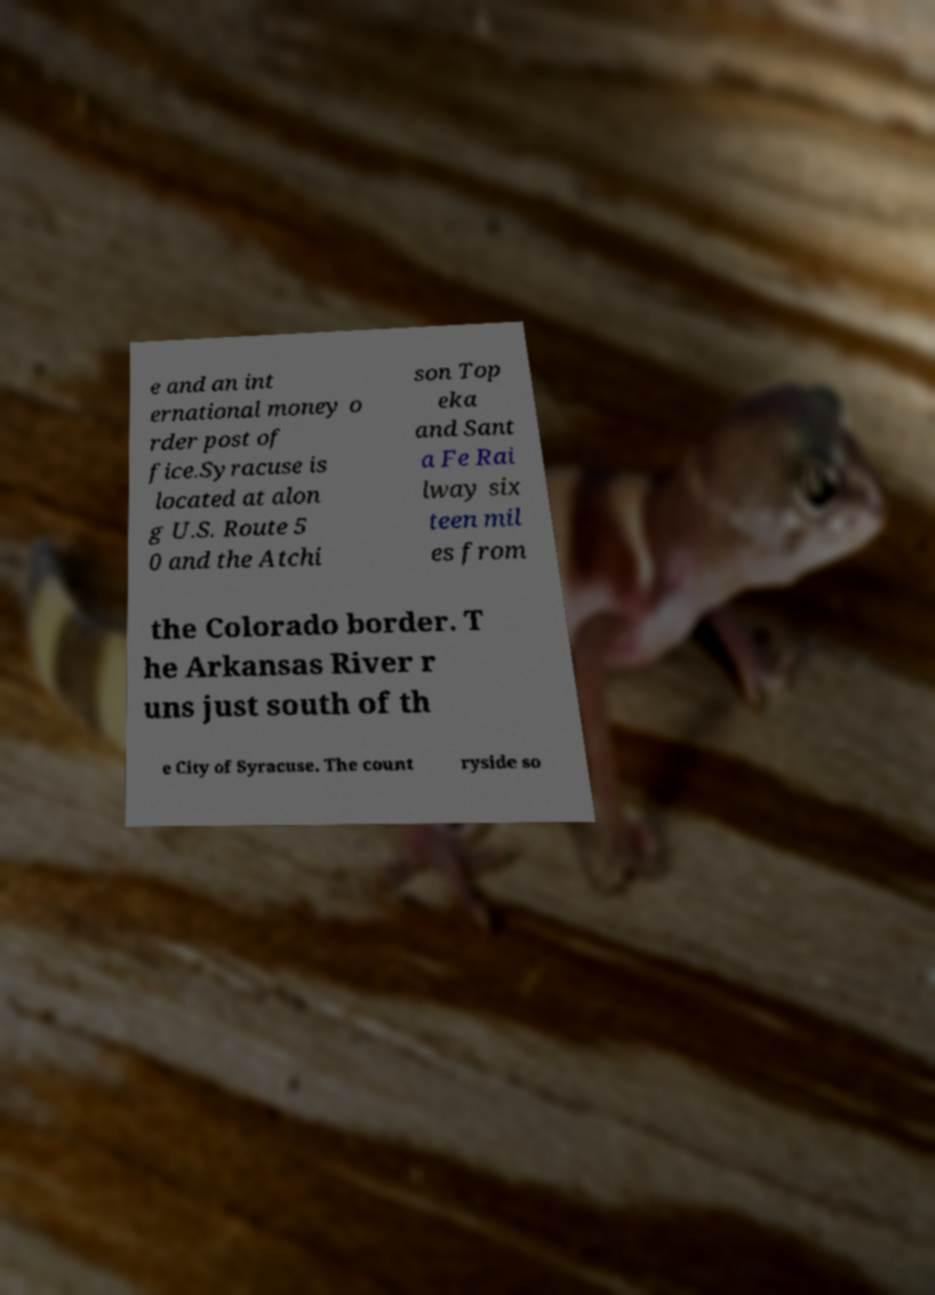Please identify and transcribe the text found in this image. e and an int ernational money o rder post of fice.Syracuse is located at alon g U.S. Route 5 0 and the Atchi son Top eka and Sant a Fe Rai lway six teen mil es from the Colorado border. T he Arkansas River r uns just south of th e City of Syracuse. The count ryside so 